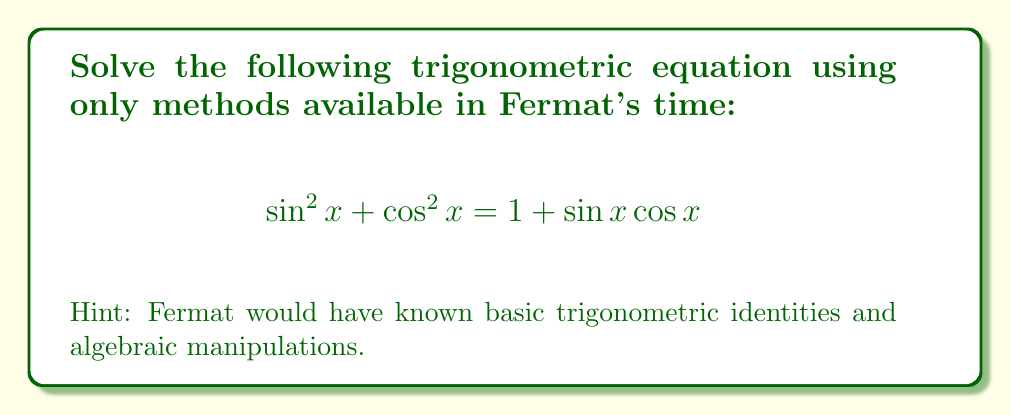Provide a solution to this math problem. Let's approach this step-by-step using methods available in Fermat's time:

1) First, recall the fundamental trigonometric identity:
   $$\sin^2 x + \cos^2 x = 1$$

2) Using this, we can rewrite the left side of our equation:
   $$1 = 1 + \sin x \cos x$$

3) Subtracting 1 from both sides:
   $$0 = \sin x \cos x$$

4) For this equation to be true, either $\sin x = 0$ or $\cos x = 0$ (or both).

5) We know that:
   $\sin x = 0$ when $x = 0, \pi, 2\pi, ...$
   $\cos x = 0$ when $x = \frac{\pi}{2}, \frac{3\pi}{2}, ...$

6) Therefore, the solutions are all multiples of $\frac{\pi}{2}$:
   $$x = 0, \frac{\pi}{2}, \pi, \frac{3\pi}{2}, 2\pi, ...$$

7) We can express this more concisely as:
   $$x = \frac{n\pi}{2}, \text{ where } n \text{ is any integer}$$

This solution uses only algebraic manipulation and basic trigonometric knowledge that would have been available in Fermat's time.
Answer: $x = \frac{n\pi}{2}, n \in \mathbb{Z}$ 